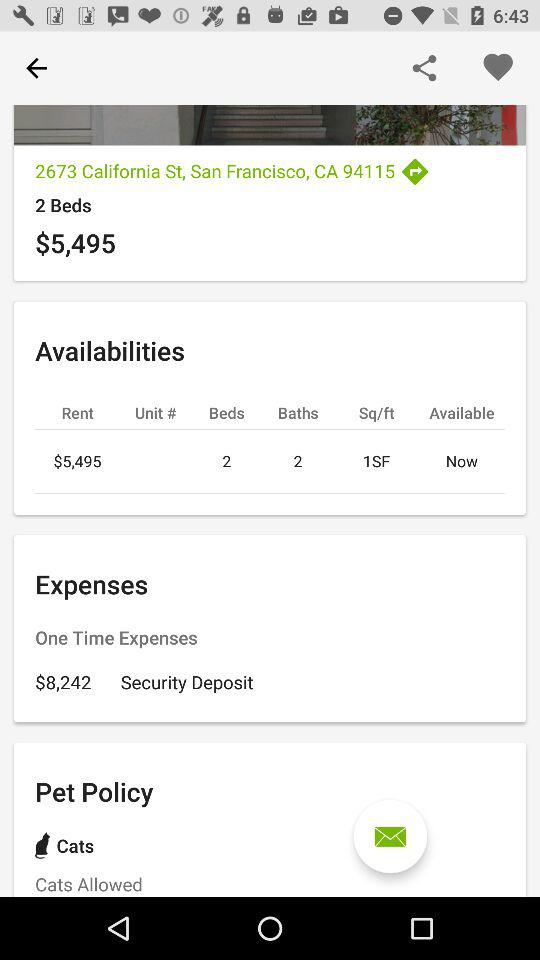How much is a one-time expense? The one-time expense is $8,242. 